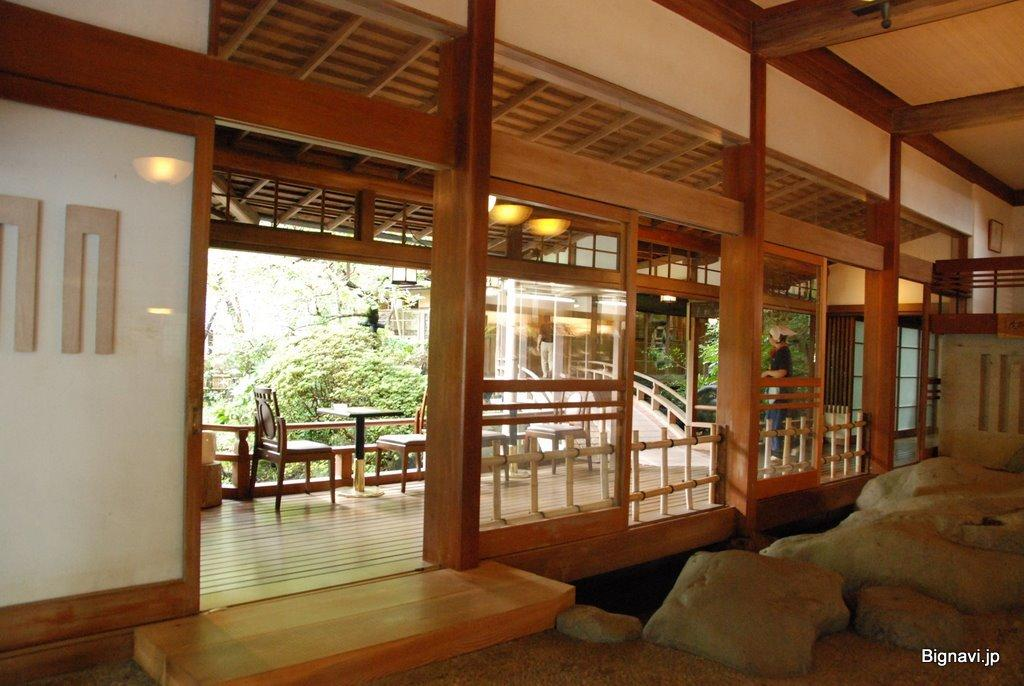What type of furniture can be seen in the image? There are chairs in the image. What architectural feature is present in the image? There are stairs in the image. What structural elements are visible in the image? There are wooden pillars in the image. What type of illumination is present in the image? There are lights in the image. What type of vegetation is present in the image? There are plants in the image. Is there a person in the image? Yes, there is a person in the image. What achievements has the team accomplished in the image? There is no team or mention of achievements in the image. What type of man is depicted in the image? The question is unclear, as there is only one person mentioned in the image, and their gender is not specified. However, based on the provided facts, we can say that there is a person in the image, but we cannot determine their gender or any specific characteristics. 